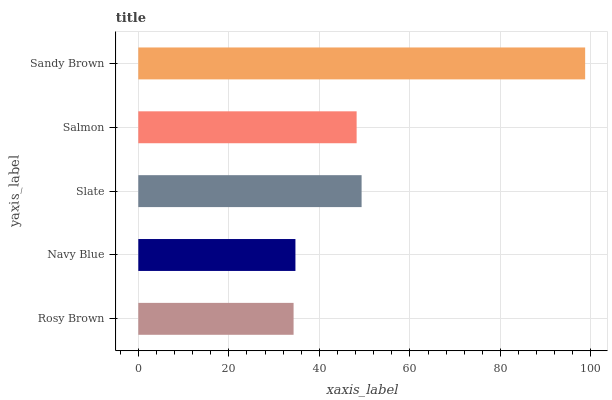Is Rosy Brown the minimum?
Answer yes or no. Yes. Is Sandy Brown the maximum?
Answer yes or no. Yes. Is Navy Blue the minimum?
Answer yes or no. No. Is Navy Blue the maximum?
Answer yes or no. No. Is Navy Blue greater than Rosy Brown?
Answer yes or no. Yes. Is Rosy Brown less than Navy Blue?
Answer yes or no. Yes. Is Rosy Brown greater than Navy Blue?
Answer yes or no. No. Is Navy Blue less than Rosy Brown?
Answer yes or no. No. Is Salmon the high median?
Answer yes or no. Yes. Is Salmon the low median?
Answer yes or no. Yes. Is Slate the high median?
Answer yes or no. No. Is Sandy Brown the low median?
Answer yes or no. No. 